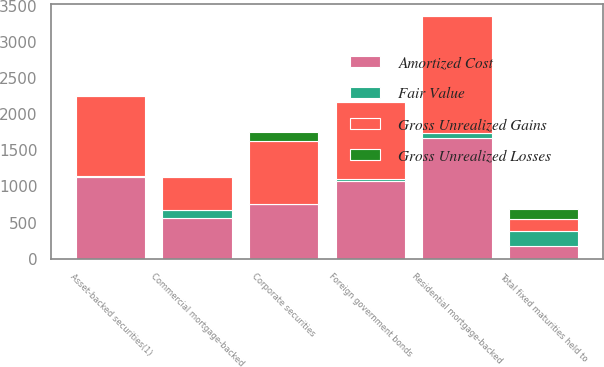<chart> <loc_0><loc_0><loc_500><loc_500><stacked_bar_chart><ecel><fcel>Foreign government bonds<fcel>Corporate securities<fcel>Asset-backed securities(1)<fcel>Commercial mortgage-backed<fcel>Residential mortgage-backed<fcel>Total fixed maturities held to<nl><fcel>Gross Unrealized Gains<fcel>1058<fcel>876<fcel>1112<fcel>460<fcel>1614<fcel>172<nl><fcel>Fair Value<fcel>25<fcel>1<fcel>16<fcel>104<fcel>65<fcel>211<nl><fcel>Gross Unrealized Losses<fcel>1<fcel>126<fcel>3<fcel>0<fcel>3<fcel>133<nl><fcel>Amortized Cost<fcel>1082<fcel>751<fcel>1125<fcel>564<fcel>1676<fcel>172<nl></chart> 